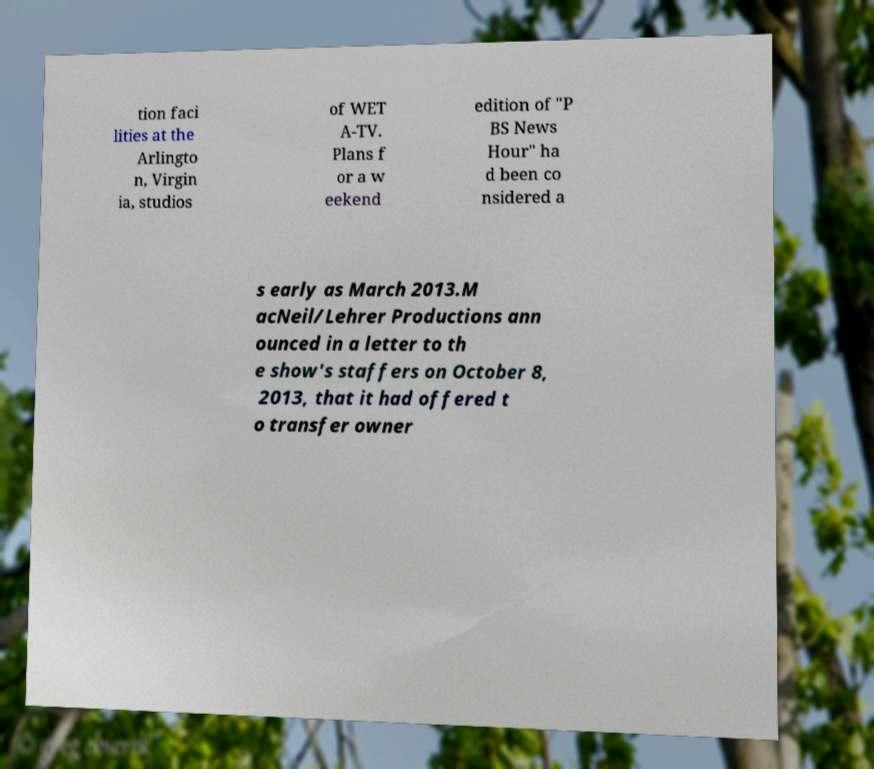For documentation purposes, I need the text within this image transcribed. Could you provide that? tion faci lities at the Arlingto n, Virgin ia, studios of WET A-TV. Plans f or a w eekend edition of "P BS News Hour" ha d been co nsidered a s early as March 2013.M acNeil/Lehrer Productions ann ounced in a letter to th e show's staffers on October 8, 2013, that it had offered t o transfer owner 